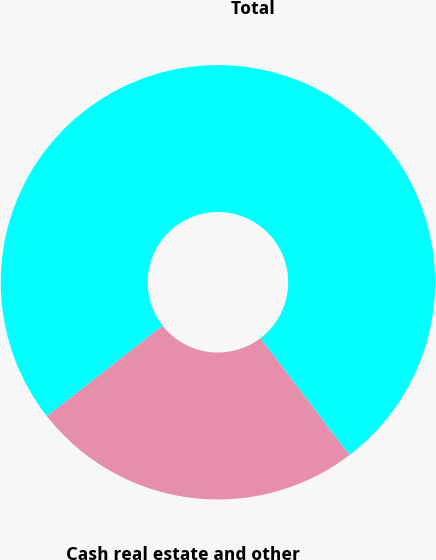<chart> <loc_0><loc_0><loc_500><loc_500><pie_chart><fcel>Cash real estate and other<fcel>Total<nl><fcel>24.81%<fcel>75.19%<nl></chart> 